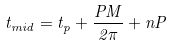Convert formula to latex. <formula><loc_0><loc_0><loc_500><loc_500>t _ { m i d } = t _ { p } + \frac { P M } { 2 \pi } + n P</formula> 